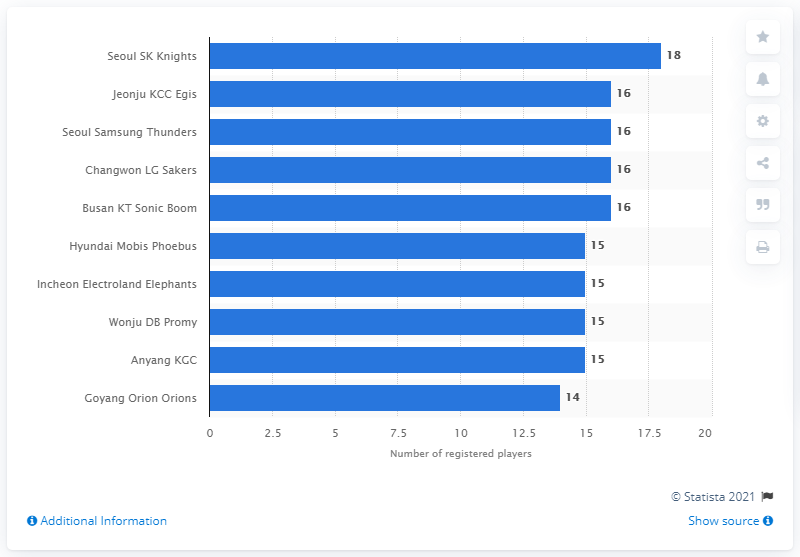Outline some significant characteristics in this image. As of the 2020/2021 season, the Seoul SK Knights had a total of 18 registered players. 